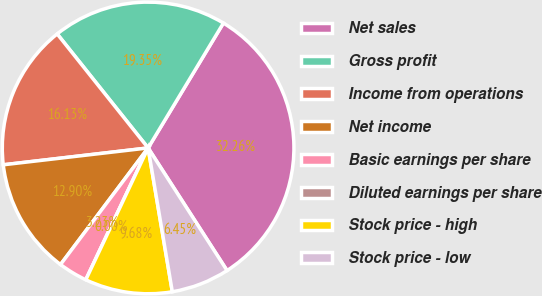Convert chart to OTSL. <chart><loc_0><loc_0><loc_500><loc_500><pie_chart><fcel>Net sales<fcel>Gross profit<fcel>Income from operations<fcel>Net income<fcel>Basic earnings per share<fcel>Diluted earnings per share<fcel>Stock price - high<fcel>Stock price - low<nl><fcel>32.26%<fcel>19.35%<fcel>16.13%<fcel>12.9%<fcel>3.23%<fcel>0.0%<fcel>9.68%<fcel>6.45%<nl></chart> 